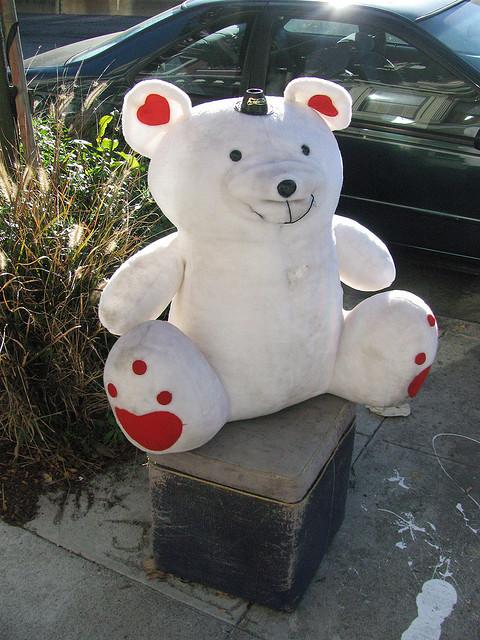Is this teddy bear able to talk about solving world hunger?
Keep it brief. No. What shape is on the ears?
Keep it brief. Heart. What color is the bear?
Give a very brief answer. White. 